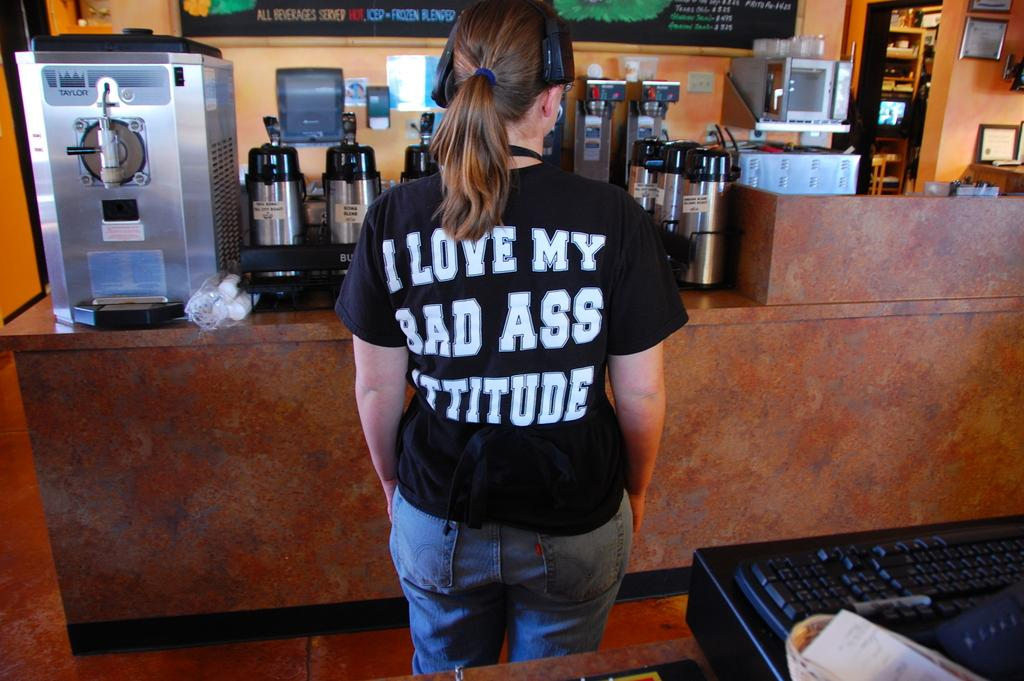<image>
Render a clear and concise summary of the photo. employee with headphones at a drink station wearing a bad ass attitude shirt 